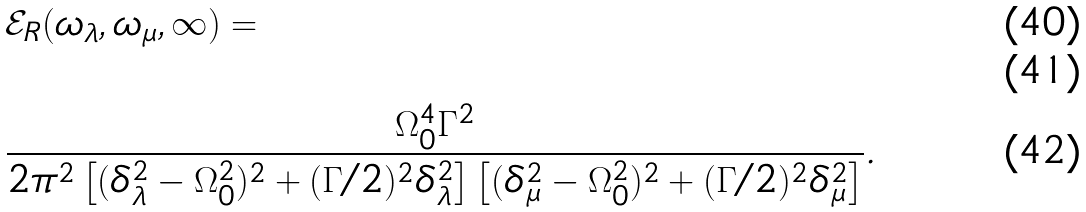Convert formula to latex. <formula><loc_0><loc_0><loc_500><loc_500>& \mathcal { E } _ { R } ( \omega _ { \lambda } , \omega _ { \mu } , \infty ) = \\ \\ & \frac { \Omega ^ { 4 } _ { 0 } \Gamma ^ { 2 } } { 2 \pi ^ { 2 } \left [ ( \delta ^ { 2 } _ { \lambda } - \Omega ^ { 2 } _ { 0 } ) ^ { 2 } + ( \Gamma / 2 ) ^ { 2 } \delta ^ { 2 } _ { \lambda } \right ] \left [ ( \delta ^ { 2 } _ { \mu } - \Omega ^ { 2 } _ { 0 } ) ^ { 2 } + ( \Gamma / 2 ) ^ { 2 } \delta ^ { 2 } _ { \mu } \right ] } .</formula> 